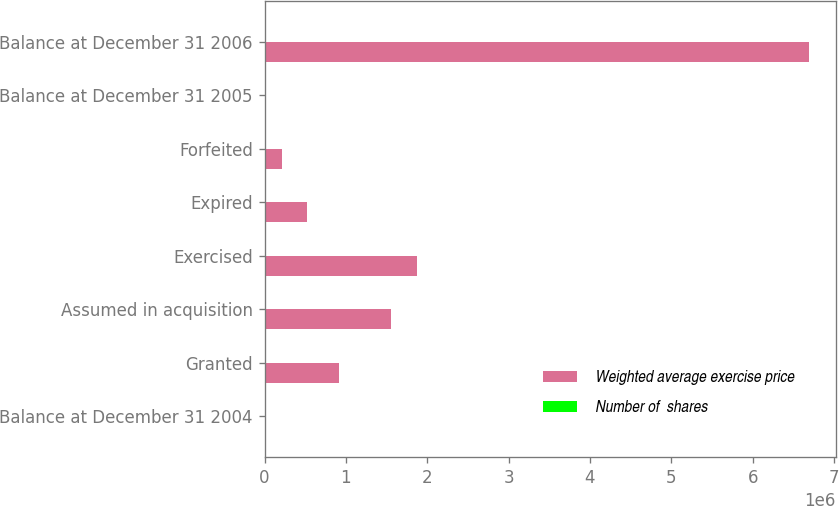<chart> <loc_0><loc_0><loc_500><loc_500><stacked_bar_chart><ecel><fcel>Balance at December 31 2004<fcel>Granted<fcel>Assumed in acquisition<fcel>Exercised<fcel>Expired<fcel>Forfeited<fcel>Balance at December 31 2005<fcel>Balance at December 31 2006<nl><fcel>Weighted average exercise price<fcel>68.95<fcel>912905<fcel>1.55969e+06<fcel>1.87275e+06<fcel>519521<fcel>216533<fcel>68.95<fcel>6.68679e+06<nl><fcel>Number of  shares<fcel>51.98<fcel>71.37<fcel>47.44<fcel>50<fcel>66.53<fcel>55.46<fcel>52.79<fcel>57.62<nl></chart> 